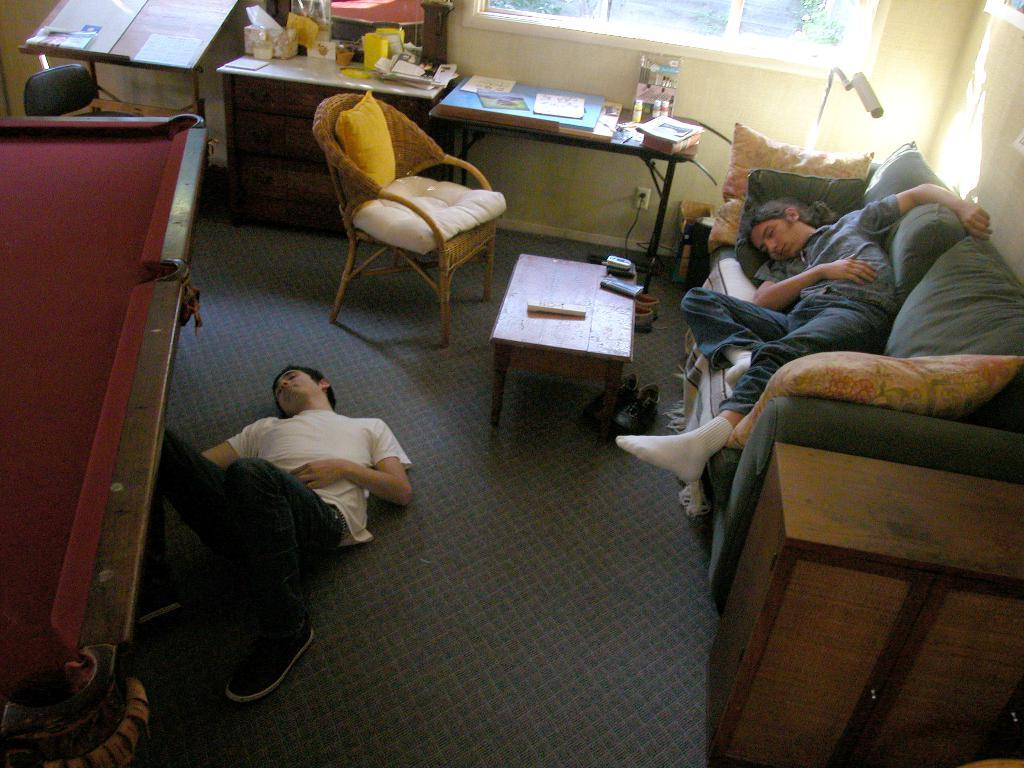What is the main activity of the people in the image? The people in the image are laying down, one on a couch and the other on a carpet. What furniture can be seen in the background of the image? There is a chair, a pillow, a table, and a snookers board in the background of the image. What objects are present on the table in the background? There are books and a light on the table in the background. What type of bun is being served with the popcorn in the image? There is no popcorn or bun present in the image. How does the person on the couch breathe while laying down? The person on the couch is not shown breathing in the image, but it can be assumed that they are breathing normally while laying down. 